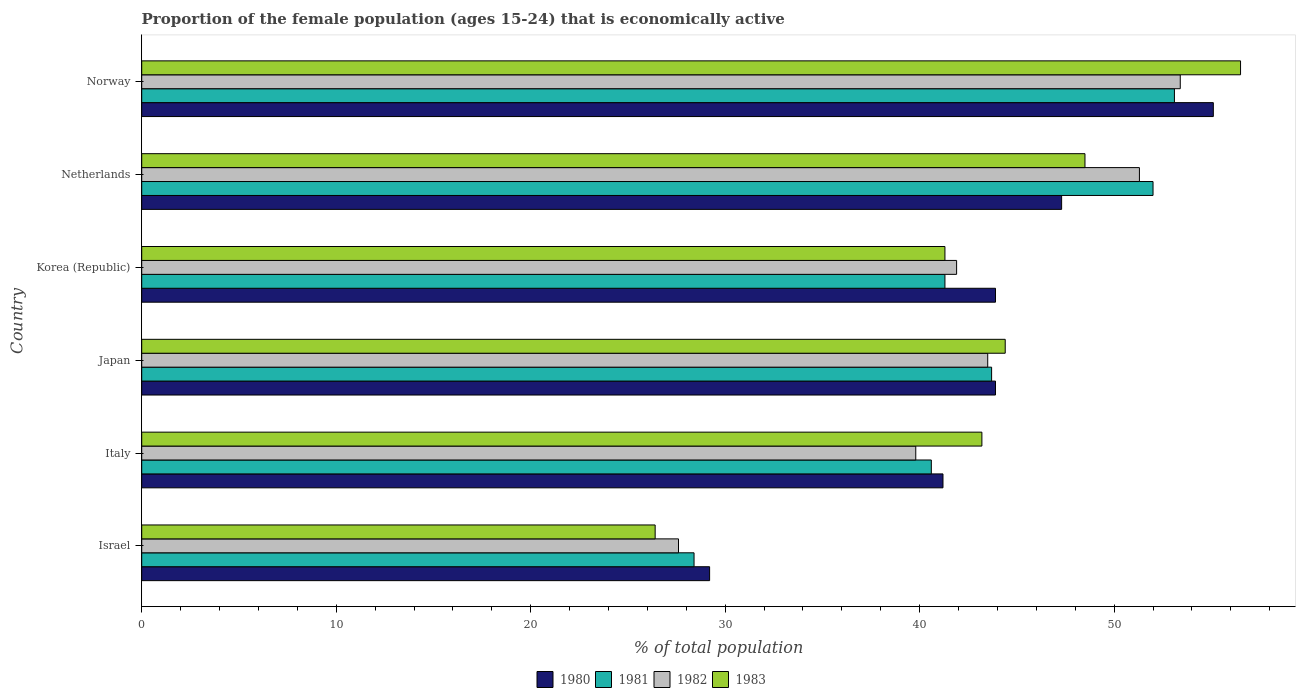How many different coloured bars are there?
Your response must be concise. 4. Are the number of bars per tick equal to the number of legend labels?
Offer a very short reply. Yes. Are the number of bars on each tick of the Y-axis equal?
Provide a short and direct response. Yes. How many bars are there on the 2nd tick from the top?
Offer a terse response. 4. What is the label of the 5th group of bars from the top?
Provide a short and direct response. Italy. In how many cases, is the number of bars for a given country not equal to the number of legend labels?
Provide a succinct answer. 0. What is the proportion of the female population that is economically active in 1980 in Norway?
Provide a short and direct response. 55.1. Across all countries, what is the maximum proportion of the female population that is economically active in 1982?
Your response must be concise. 53.4. Across all countries, what is the minimum proportion of the female population that is economically active in 1981?
Offer a terse response. 28.4. In which country was the proportion of the female population that is economically active in 1983 maximum?
Your answer should be compact. Norway. In which country was the proportion of the female population that is economically active in 1982 minimum?
Keep it short and to the point. Israel. What is the total proportion of the female population that is economically active in 1981 in the graph?
Provide a short and direct response. 259.1. What is the difference between the proportion of the female population that is economically active in 1980 in Japan and that in Netherlands?
Your answer should be compact. -3.4. What is the difference between the proportion of the female population that is economically active in 1981 in Korea (Republic) and the proportion of the female population that is economically active in 1983 in Netherlands?
Make the answer very short. -7.2. What is the average proportion of the female population that is economically active in 1980 per country?
Provide a short and direct response. 43.43. What is the difference between the proportion of the female population that is economically active in 1983 and proportion of the female population that is economically active in 1980 in Korea (Republic)?
Provide a short and direct response. -2.6. What is the ratio of the proportion of the female population that is economically active in 1980 in Israel to that in Korea (Republic)?
Ensure brevity in your answer.  0.67. What is the difference between the highest and the second highest proportion of the female population that is economically active in 1982?
Your answer should be very brief. 2.1. What is the difference between the highest and the lowest proportion of the female population that is economically active in 1980?
Your answer should be compact. 25.9. In how many countries, is the proportion of the female population that is economically active in 1980 greater than the average proportion of the female population that is economically active in 1980 taken over all countries?
Your answer should be compact. 4. Is it the case that in every country, the sum of the proportion of the female population that is economically active in 1981 and proportion of the female population that is economically active in 1980 is greater than the sum of proportion of the female population that is economically active in 1983 and proportion of the female population that is economically active in 1982?
Keep it short and to the point. No. Is it the case that in every country, the sum of the proportion of the female population that is economically active in 1983 and proportion of the female population that is economically active in 1980 is greater than the proportion of the female population that is economically active in 1981?
Provide a short and direct response. Yes. Are all the bars in the graph horizontal?
Your response must be concise. Yes. What is the difference between two consecutive major ticks on the X-axis?
Provide a succinct answer. 10. Are the values on the major ticks of X-axis written in scientific E-notation?
Your answer should be compact. No. Does the graph contain grids?
Offer a very short reply. No. How many legend labels are there?
Your response must be concise. 4. What is the title of the graph?
Your response must be concise. Proportion of the female population (ages 15-24) that is economically active. What is the label or title of the X-axis?
Offer a terse response. % of total population. What is the % of total population of 1980 in Israel?
Offer a terse response. 29.2. What is the % of total population of 1981 in Israel?
Ensure brevity in your answer.  28.4. What is the % of total population of 1982 in Israel?
Provide a short and direct response. 27.6. What is the % of total population in 1983 in Israel?
Your answer should be very brief. 26.4. What is the % of total population of 1980 in Italy?
Keep it short and to the point. 41.2. What is the % of total population in 1981 in Italy?
Offer a very short reply. 40.6. What is the % of total population in 1982 in Italy?
Provide a succinct answer. 39.8. What is the % of total population of 1983 in Italy?
Ensure brevity in your answer.  43.2. What is the % of total population of 1980 in Japan?
Offer a terse response. 43.9. What is the % of total population of 1981 in Japan?
Provide a succinct answer. 43.7. What is the % of total population of 1982 in Japan?
Your response must be concise. 43.5. What is the % of total population of 1983 in Japan?
Your answer should be very brief. 44.4. What is the % of total population in 1980 in Korea (Republic)?
Keep it short and to the point. 43.9. What is the % of total population in 1981 in Korea (Republic)?
Offer a very short reply. 41.3. What is the % of total population of 1982 in Korea (Republic)?
Your response must be concise. 41.9. What is the % of total population in 1983 in Korea (Republic)?
Your response must be concise. 41.3. What is the % of total population in 1980 in Netherlands?
Offer a terse response. 47.3. What is the % of total population in 1982 in Netherlands?
Keep it short and to the point. 51.3. What is the % of total population of 1983 in Netherlands?
Your answer should be very brief. 48.5. What is the % of total population in 1980 in Norway?
Provide a succinct answer. 55.1. What is the % of total population in 1981 in Norway?
Offer a very short reply. 53.1. What is the % of total population of 1982 in Norway?
Make the answer very short. 53.4. What is the % of total population of 1983 in Norway?
Your answer should be compact. 56.5. Across all countries, what is the maximum % of total population of 1980?
Your answer should be very brief. 55.1. Across all countries, what is the maximum % of total population in 1981?
Keep it short and to the point. 53.1. Across all countries, what is the maximum % of total population of 1982?
Provide a succinct answer. 53.4. Across all countries, what is the maximum % of total population of 1983?
Your answer should be compact. 56.5. Across all countries, what is the minimum % of total population in 1980?
Your answer should be very brief. 29.2. Across all countries, what is the minimum % of total population of 1981?
Offer a very short reply. 28.4. Across all countries, what is the minimum % of total population in 1982?
Ensure brevity in your answer.  27.6. Across all countries, what is the minimum % of total population in 1983?
Make the answer very short. 26.4. What is the total % of total population of 1980 in the graph?
Offer a terse response. 260.6. What is the total % of total population of 1981 in the graph?
Provide a succinct answer. 259.1. What is the total % of total population of 1982 in the graph?
Offer a terse response. 257.5. What is the total % of total population in 1983 in the graph?
Your response must be concise. 260.3. What is the difference between the % of total population in 1980 in Israel and that in Italy?
Keep it short and to the point. -12. What is the difference between the % of total population in 1983 in Israel and that in Italy?
Provide a succinct answer. -16.8. What is the difference between the % of total population in 1980 in Israel and that in Japan?
Provide a succinct answer. -14.7. What is the difference between the % of total population of 1981 in Israel and that in Japan?
Make the answer very short. -15.3. What is the difference between the % of total population of 1982 in Israel and that in Japan?
Give a very brief answer. -15.9. What is the difference between the % of total population of 1983 in Israel and that in Japan?
Your answer should be compact. -18. What is the difference between the % of total population in 1980 in Israel and that in Korea (Republic)?
Keep it short and to the point. -14.7. What is the difference between the % of total population in 1982 in Israel and that in Korea (Republic)?
Make the answer very short. -14.3. What is the difference between the % of total population of 1983 in Israel and that in Korea (Republic)?
Your answer should be compact. -14.9. What is the difference between the % of total population of 1980 in Israel and that in Netherlands?
Give a very brief answer. -18.1. What is the difference between the % of total population of 1981 in Israel and that in Netherlands?
Provide a succinct answer. -23.6. What is the difference between the % of total population of 1982 in Israel and that in Netherlands?
Your response must be concise. -23.7. What is the difference between the % of total population of 1983 in Israel and that in Netherlands?
Your answer should be very brief. -22.1. What is the difference between the % of total population of 1980 in Israel and that in Norway?
Ensure brevity in your answer.  -25.9. What is the difference between the % of total population in 1981 in Israel and that in Norway?
Make the answer very short. -24.7. What is the difference between the % of total population in 1982 in Israel and that in Norway?
Give a very brief answer. -25.8. What is the difference between the % of total population in 1983 in Israel and that in Norway?
Your answer should be compact. -30.1. What is the difference between the % of total population of 1981 in Italy and that in Japan?
Offer a very short reply. -3.1. What is the difference between the % of total population of 1982 in Italy and that in Japan?
Keep it short and to the point. -3.7. What is the difference between the % of total population in 1983 in Italy and that in Japan?
Give a very brief answer. -1.2. What is the difference between the % of total population in 1981 in Italy and that in Korea (Republic)?
Offer a terse response. -0.7. What is the difference between the % of total population in 1983 in Italy and that in Korea (Republic)?
Provide a succinct answer. 1.9. What is the difference between the % of total population of 1983 in Italy and that in Netherlands?
Make the answer very short. -5.3. What is the difference between the % of total population of 1980 in Japan and that in Korea (Republic)?
Keep it short and to the point. 0. What is the difference between the % of total population in 1981 in Japan and that in Korea (Republic)?
Give a very brief answer. 2.4. What is the difference between the % of total population of 1981 in Japan and that in Netherlands?
Ensure brevity in your answer.  -8.3. What is the difference between the % of total population of 1983 in Japan and that in Netherlands?
Your response must be concise. -4.1. What is the difference between the % of total population in 1980 in Japan and that in Norway?
Provide a short and direct response. -11.2. What is the difference between the % of total population of 1982 in Japan and that in Norway?
Provide a succinct answer. -9.9. What is the difference between the % of total population in 1983 in Japan and that in Norway?
Offer a very short reply. -12.1. What is the difference between the % of total population in 1980 in Korea (Republic) and that in Netherlands?
Your answer should be very brief. -3.4. What is the difference between the % of total population of 1981 in Korea (Republic) and that in Netherlands?
Provide a succinct answer. -10.7. What is the difference between the % of total population in 1982 in Korea (Republic) and that in Netherlands?
Offer a terse response. -9.4. What is the difference between the % of total population in 1981 in Korea (Republic) and that in Norway?
Provide a short and direct response. -11.8. What is the difference between the % of total population of 1983 in Korea (Republic) and that in Norway?
Provide a short and direct response. -15.2. What is the difference between the % of total population in 1982 in Netherlands and that in Norway?
Provide a succinct answer. -2.1. What is the difference between the % of total population in 1983 in Netherlands and that in Norway?
Provide a short and direct response. -8. What is the difference between the % of total population of 1981 in Israel and the % of total population of 1983 in Italy?
Your response must be concise. -14.8. What is the difference between the % of total population of 1982 in Israel and the % of total population of 1983 in Italy?
Give a very brief answer. -15.6. What is the difference between the % of total population of 1980 in Israel and the % of total population of 1982 in Japan?
Offer a terse response. -14.3. What is the difference between the % of total population of 1980 in Israel and the % of total population of 1983 in Japan?
Make the answer very short. -15.2. What is the difference between the % of total population in 1981 in Israel and the % of total population in 1982 in Japan?
Provide a succinct answer. -15.1. What is the difference between the % of total population of 1982 in Israel and the % of total population of 1983 in Japan?
Offer a very short reply. -16.8. What is the difference between the % of total population in 1980 in Israel and the % of total population in 1981 in Korea (Republic)?
Your answer should be very brief. -12.1. What is the difference between the % of total population of 1980 in Israel and the % of total population of 1982 in Korea (Republic)?
Your answer should be very brief. -12.7. What is the difference between the % of total population of 1980 in Israel and the % of total population of 1983 in Korea (Republic)?
Offer a terse response. -12.1. What is the difference between the % of total population of 1981 in Israel and the % of total population of 1983 in Korea (Republic)?
Offer a terse response. -12.9. What is the difference between the % of total population in 1982 in Israel and the % of total population in 1983 in Korea (Republic)?
Give a very brief answer. -13.7. What is the difference between the % of total population of 1980 in Israel and the % of total population of 1981 in Netherlands?
Your answer should be very brief. -22.8. What is the difference between the % of total population of 1980 in Israel and the % of total population of 1982 in Netherlands?
Make the answer very short. -22.1. What is the difference between the % of total population in 1980 in Israel and the % of total population in 1983 in Netherlands?
Your answer should be compact. -19.3. What is the difference between the % of total population of 1981 in Israel and the % of total population of 1982 in Netherlands?
Your answer should be very brief. -22.9. What is the difference between the % of total population of 1981 in Israel and the % of total population of 1983 in Netherlands?
Make the answer very short. -20.1. What is the difference between the % of total population in 1982 in Israel and the % of total population in 1983 in Netherlands?
Ensure brevity in your answer.  -20.9. What is the difference between the % of total population of 1980 in Israel and the % of total population of 1981 in Norway?
Offer a very short reply. -23.9. What is the difference between the % of total population in 1980 in Israel and the % of total population in 1982 in Norway?
Provide a succinct answer. -24.2. What is the difference between the % of total population of 1980 in Israel and the % of total population of 1983 in Norway?
Your response must be concise. -27.3. What is the difference between the % of total population in 1981 in Israel and the % of total population in 1983 in Norway?
Keep it short and to the point. -28.1. What is the difference between the % of total population in 1982 in Israel and the % of total population in 1983 in Norway?
Keep it short and to the point. -28.9. What is the difference between the % of total population in 1980 in Italy and the % of total population in 1981 in Japan?
Your answer should be compact. -2.5. What is the difference between the % of total population in 1980 in Italy and the % of total population in 1982 in Japan?
Provide a succinct answer. -2.3. What is the difference between the % of total population in 1980 in Italy and the % of total population in 1983 in Japan?
Offer a terse response. -3.2. What is the difference between the % of total population in 1981 in Italy and the % of total population in 1983 in Japan?
Offer a very short reply. -3.8. What is the difference between the % of total population of 1982 in Italy and the % of total population of 1983 in Japan?
Your answer should be compact. -4.6. What is the difference between the % of total population in 1980 in Italy and the % of total population in 1981 in Korea (Republic)?
Keep it short and to the point. -0.1. What is the difference between the % of total population of 1980 in Italy and the % of total population of 1983 in Korea (Republic)?
Provide a succinct answer. -0.1. What is the difference between the % of total population of 1981 in Italy and the % of total population of 1983 in Korea (Republic)?
Give a very brief answer. -0.7. What is the difference between the % of total population in 1980 in Italy and the % of total population in 1982 in Netherlands?
Your response must be concise. -10.1. What is the difference between the % of total population in 1980 in Italy and the % of total population in 1983 in Netherlands?
Make the answer very short. -7.3. What is the difference between the % of total population of 1980 in Italy and the % of total population of 1981 in Norway?
Provide a short and direct response. -11.9. What is the difference between the % of total population of 1980 in Italy and the % of total population of 1982 in Norway?
Your answer should be compact. -12.2. What is the difference between the % of total population of 1980 in Italy and the % of total population of 1983 in Norway?
Make the answer very short. -15.3. What is the difference between the % of total population in 1981 in Italy and the % of total population in 1983 in Norway?
Give a very brief answer. -15.9. What is the difference between the % of total population in 1982 in Italy and the % of total population in 1983 in Norway?
Give a very brief answer. -16.7. What is the difference between the % of total population in 1980 in Japan and the % of total population in 1981 in Korea (Republic)?
Ensure brevity in your answer.  2.6. What is the difference between the % of total population of 1980 in Japan and the % of total population of 1982 in Korea (Republic)?
Ensure brevity in your answer.  2. What is the difference between the % of total population of 1980 in Japan and the % of total population of 1983 in Korea (Republic)?
Offer a very short reply. 2.6. What is the difference between the % of total population of 1981 in Japan and the % of total population of 1983 in Korea (Republic)?
Offer a terse response. 2.4. What is the difference between the % of total population in 1980 in Japan and the % of total population in 1982 in Netherlands?
Give a very brief answer. -7.4. What is the difference between the % of total population of 1981 in Japan and the % of total population of 1982 in Netherlands?
Keep it short and to the point. -7.6. What is the difference between the % of total population in 1981 in Japan and the % of total population in 1982 in Norway?
Provide a short and direct response. -9.7. What is the difference between the % of total population in 1982 in Japan and the % of total population in 1983 in Norway?
Ensure brevity in your answer.  -13. What is the difference between the % of total population of 1980 in Korea (Republic) and the % of total population of 1981 in Netherlands?
Your answer should be compact. -8.1. What is the difference between the % of total population in 1980 in Korea (Republic) and the % of total population in 1982 in Netherlands?
Your answer should be compact. -7.4. What is the difference between the % of total population of 1981 in Korea (Republic) and the % of total population of 1982 in Netherlands?
Provide a succinct answer. -10. What is the difference between the % of total population of 1981 in Korea (Republic) and the % of total population of 1983 in Netherlands?
Offer a terse response. -7.2. What is the difference between the % of total population in 1980 in Korea (Republic) and the % of total population in 1982 in Norway?
Ensure brevity in your answer.  -9.5. What is the difference between the % of total population of 1981 in Korea (Republic) and the % of total population of 1982 in Norway?
Make the answer very short. -12.1. What is the difference between the % of total population of 1981 in Korea (Republic) and the % of total population of 1983 in Norway?
Keep it short and to the point. -15.2. What is the difference between the % of total population of 1982 in Korea (Republic) and the % of total population of 1983 in Norway?
Offer a terse response. -14.6. What is the difference between the % of total population of 1982 in Netherlands and the % of total population of 1983 in Norway?
Make the answer very short. -5.2. What is the average % of total population in 1980 per country?
Keep it short and to the point. 43.43. What is the average % of total population in 1981 per country?
Your response must be concise. 43.18. What is the average % of total population in 1982 per country?
Keep it short and to the point. 42.92. What is the average % of total population of 1983 per country?
Keep it short and to the point. 43.38. What is the difference between the % of total population of 1980 and % of total population of 1983 in Israel?
Your response must be concise. 2.8. What is the difference between the % of total population in 1981 and % of total population in 1983 in Israel?
Provide a succinct answer. 2. What is the difference between the % of total population in 1980 and % of total population in 1982 in Italy?
Your response must be concise. 1.4. What is the difference between the % of total population of 1981 and % of total population of 1982 in Italy?
Give a very brief answer. 0.8. What is the difference between the % of total population of 1982 and % of total population of 1983 in Italy?
Give a very brief answer. -3.4. What is the difference between the % of total population of 1980 and % of total population of 1981 in Japan?
Your answer should be very brief. 0.2. What is the difference between the % of total population in 1980 and % of total population in 1982 in Japan?
Make the answer very short. 0.4. What is the difference between the % of total population in 1980 and % of total population in 1983 in Japan?
Make the answer very short. -0.5. What is the difference between the % of total population of 1981 and % of total population of 1982 in Japan?
Provide a succinct answer. 0.2. What is the difference between the % of total population of 1982 and % of total population of 1983 in Japan?
Offer a terse response. -0.9. What is the difference between the % of total population in 1980 and % of total population in 1981 in Korea (Republic)?
Make the answer very short. 2.6. What is the difference between the % of total population of 1980 and % of total population of 1982 in Korea (Republic)?
Offer a very short reply. 2. What is the difference between the % of total population of 1980 and % of total population of 1983 in Korea (Republic)?
Make the answer very short. 2.6. What is the difference between the % of total population in 1981 and % of total population in 1982 in Korea (Republic)?
Provide a succinct answer. -0.6. What is the difference between the % of total population of 1980 and % of total population of 1981 in Netherlands?
Provide a succinct answer. -4.7. What is the difference between the % of total population in 1980 and % of total population in 1983 in Netherlands?
Offer a very short reply. -1.2. What is the difference between the % of total population in 1981 and % of total population in 1982 in Netherlands?
Make the answer very short. 0.7. What is the difference between the % of total population in 1982 and % of total population in 1983 in Netherlands?
Your response must be concise. 2.8. What is the difference between the % of total population of 1980 and % of total population of 1983 in Norway?
Ensure brevity in your answer.  -1.4. What is the difference between the % of total population of 1981 and % of total population of 1982 in Norway?
Your answer should be very brief. -0.3. What is the difference between the % of total population of 1981 and % of total population of 1983 in Norway?
Offer a very short reply. -3.4. What is the ratio of the % of total population in 1980 in Israel to that in Italy?
Keep it short and to the point. 0.71. What is the ratio of the % of total population of 1981 in Israel to that in Italy?
Ensure brevity in your answer.  0.7. What is the ratio of the % of total population in 1982 in Israel to that in Italy?
Your answer should be compact. 0.69. What is the ratio of the % of total population in 1983 in Israel to that in Italy?
Your answer should be compact. 0.61. What is the ratio of the % of total population in 1980 in Israel to that in Japan?
Your answer should be very brief. 0.67. What is the ratio of the % of total population in 1981 in Israel to that in Japan?
Give a very brief answer. 0.65. What is the ratio of the % of total population in 1982 in Israel to that in Japan?
Offer a terse response. 0.63. What is the ratio of the % of total population in 1983 in Israel to that in Japan?
Ensure brevity in your answer.  0.59. What is the ratio of the % of total population in 1980 in Israel to that in Korea (Republic)?
Offer a very short reply. 0.67. What is the ratio of the % of total population in 1981 in Israel to that in Korea (Republic)?
Your response must be concise. 0.69. What is the ratio of the % of total population of 1982 in Israel to that in Korea (Republic)?
Make the answer very short. 0.66. What is the ratio of the % of total population in 1983 in Israel to that in Korea (Republic)?
Your answer should be compact. 0.64. What is the ratio of the % of total population of 1980 in Israel to that in Netherlands?
Keep it short and to the point. 0.62. What is the ratio of the % of total population in 1981 in Israel to that in Netherlands?
Ensure brevity in your answer.  0.55. What is the ratio of the % of total population in 1982 in Israel to that in Netherlands?
Give a very brief answer. 0.54. What is the ratio of the % of total population in 1983 in Israel to that in Netherlands?
Give a very brief answer. 0.54. What is the ratio of the % of total population in 1980 in Israel to that in Norway?
Offer a very short reply. 0.53. What is the ratio of the % of total population in 1981 in Israel to that in Norway?
Offer a terse response. 0.53. What is the ratio of the % of total population of 1982 in Israel to that in Norway?
Your answer should be very brief. 0.52. What is the ratio of the % of total population of 1983 in Israel to that in Norway?
Ensure brevity in your answer.  0.47. What is the ratio of the % of total population of 1980 in Italy to that in Japan?
Make the answer very short. 0.94. What is the ratio of the % of total population of 1981 in Italy to that in Japan?
Make the answer very short. 0.93. What is the ratio of the % of total population of 1982 in Italy to that in Japan?
Provide a succinct answer. 0.91. What is the ratio of the % of total population in 1983 in Italy to that in Japan?
Give a very brief answer. 0.97. What is the ratio of the % of total population in 1980 in Italy to that in Korea (Republic)?
Make the answer very short. 0.94. What is the ratio of the % of total population of 1981 in Italy to that in Korea (Republic)?
Offer a terse response. 0.98. What is the ratio of the % of total population of 1982 in Italy to that in Korea (Republic)?
Ensure brevity in your answer.  0.95. What is the ratio of the % of total population of 1983 in Italy to that in Korea (Republic)?
Ensure brevity in your answer.  1.05. What is the ratio of the % of total population in 1980 in Italy to that in Netherlands?
Make the answer very short. 0.87. What is the ratio of the % of total population in 1981 in Italy to that in Netherlands?
Provide a succinct answer. 0.78. What is the ratio of the % of total population in 1982 in Italy to that in Netherlands?
Offer a terse response. 0.78. What is the ratio of the % of total population of 1983 in Italy to that in Netherlands?
Offer a very short reply. 0.89. What is the ratio of the % of total population of 1980 in Italy to that in Norway?
Give a very brief answer. 0.75. What is the ratio of the % of total population of 1981 in Italy to that in Norway?
Your answer should be very brief. 0.76. What is the ratio of the % of total population of 1982 in Italy to that in Norway?
Your answer should be very brief. 0.75. What is the ratio of the % of total population of 1983 in Italy to that in Norway?
Make the answer very short. 0.76. What is the ratio of the % of total population in 1980 in Japan to that in Korea (Republic)?
Keep it short and to the point. 1. What is the ratio of the % of total population of 1981 in Japan to that in Korea (Republic)?
Keep it short and to the point. 1.06. What is the ratio of the % of total population in 1982 in Japan to that in Korea (Republic)?
Offer a very short reply. 1.04. What is the ratio of the % of total population in 1983 in Japan to that in Korea (Republic)?
Offer a terse response. 1.08. What is the ratio of the % of total population in 1980 in Japan to that in Netherlands?
Offer a terse response. 0.93. What is the ratio of the % of total population in 1981 in Japan to that in Netherlands?
Your response must be concise. 0.84. What is the ratio of the % of total population of 1982 in Japan to that in Netherlands?
Keep it short and to the point. 0.85. What is the ratio of the % of total population of 1983 in Japan to that in Netherlands?
Offer a terse response. 0.92. What is the ratio of the % of total population in 1980 in Japan to that in Norway?
Give a very brief answer. 0.8. What is the ratio of the % of total population of 1981 in Japan to that in Norway?
Your answer should be very brief. 0.82. What is the ratio of the % of total population in 1982 in Japan to that in Norway?
Provide a succinct answer. 0.81. What is the ratio of the % of total population in 1983 in Japan to that in Norway?
Offer a terse response. 0.79. What is the ratio of the % of total population of 1980 in Korea (Republic) to that in Netherlands?
Ensure brevity in your answer.  0.93. What is the ratio of the % of total population in 1981 in Korea (Republic) to that in Netherlands?
Offer a very short reply. 0.79. What is the ratio of the % of total population of 1982 in Korea (Republic) to that in Netherlands?
Provide a succinct answer. 0.82. What is the ratio of the % of total population of 1983 in Korea (Republic) to that in Netherlands?
Keep it short and to the point. 0.85. What is the ratio of the % of total population in 1980 in Korea (Republic) to that in Norway?
Make the answer very short. 0.8. What is the ratio of the % of total population in 1982 in Korea (Republic) to that in Norway?
Make the answer very short. 0.78. What is the ratio of the % of total population of 1983 in Korea (Republic) to that in Norway?
Offer a very short reply. 0.73. What is the ratio of the % of total population of 1980 in Netherlands to that in Norway?
Make the answer very short. 0.86. What is the ratio of the % of total population in 1981 in Netherlands to that in Norway?
Provide a short and direct response. 0.98. What is the ratio of the % of total population of 1982 in Netherlands to that in Norway?
Your answer should be compact. 0.96. What is the ratio of the % of total population in 1983 in Netherlands to that in Norway?
Provide a succinct answer. 0.86. What is the difference between the highest and the second highest % of total population of 1980?
Make the answer very short. 7.8. What is the difference between the highest and the second highest % of total population in 1981?
Ensure brevity in your answer.  1.1. What is the difference between the highest and the second highest % of total population of 1983?
Provide a short and direct response. 8. What is the difference between the highest and the lowest % of total population in 1980?
Your response must be concise. 25.9. What is the difference between the highest and the lowest % of total population of 1981?
Your response must be concise. 24.7. What is the difference between the highest and the lowest % of total population in 1982?
Your response must be concise. 25.8. What is the difference between the highest and the lowest % of total population of 1983?
Give a very brief answer. 30.1. 